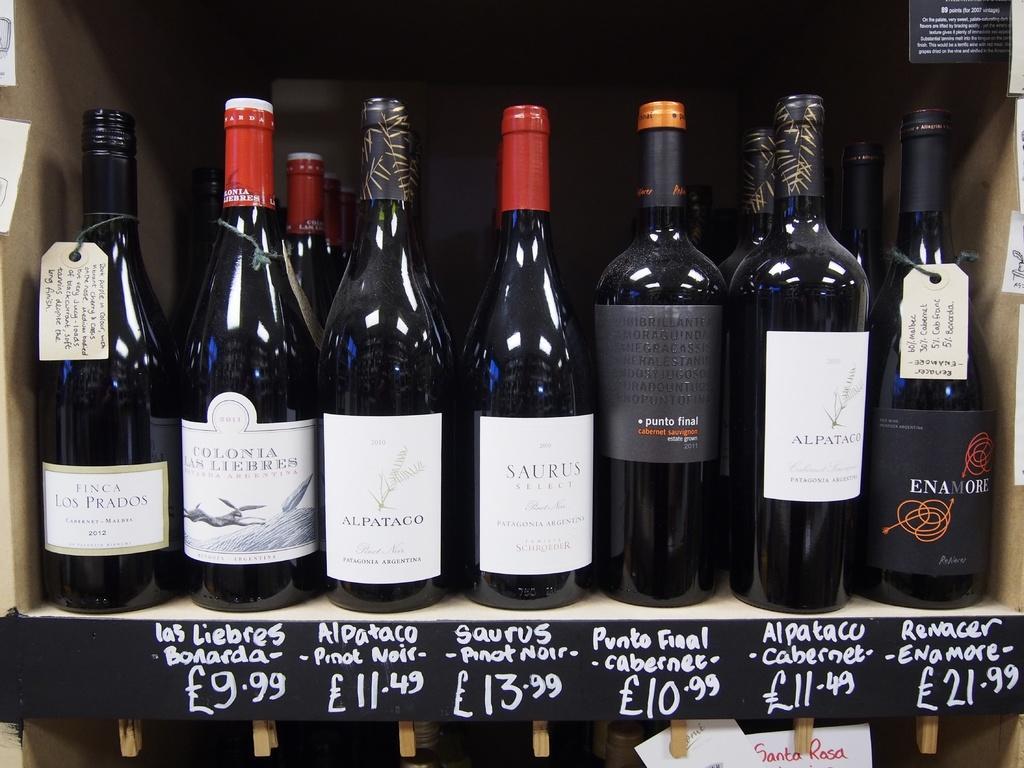Please provide a concise description of this image. In this image I can see there are many bottles kept one over the other in a box and I can see that this bottle kept for the sale 